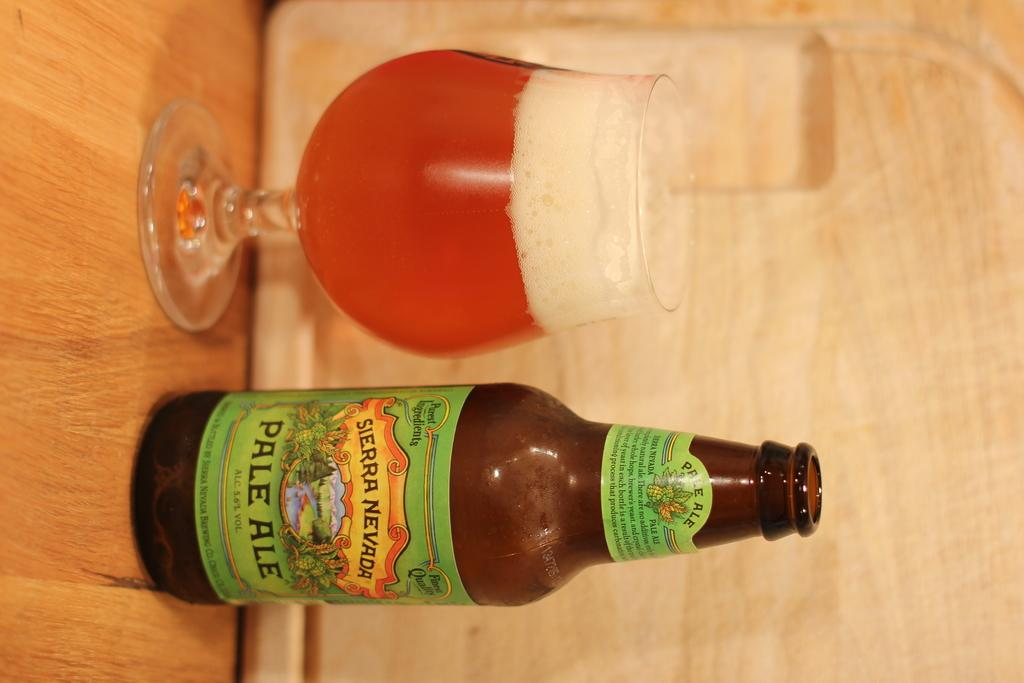<image>
Relay a brief, clear account of the picture shown. Sierra Nevada Pale Ale Beer drink next to a glass cup on the left. 